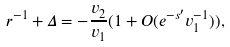<formula> <loc_0><loc_0><loc_500><loc_500>r ^ { - 1 } + \Delta = - \frac { v _ { 2 } } { v _ { 1 } } ( 1 + O ( e ^ { - s ^ { \prime } } v _ { 1 } ^ { - 1 } ) ) ,</formula> 